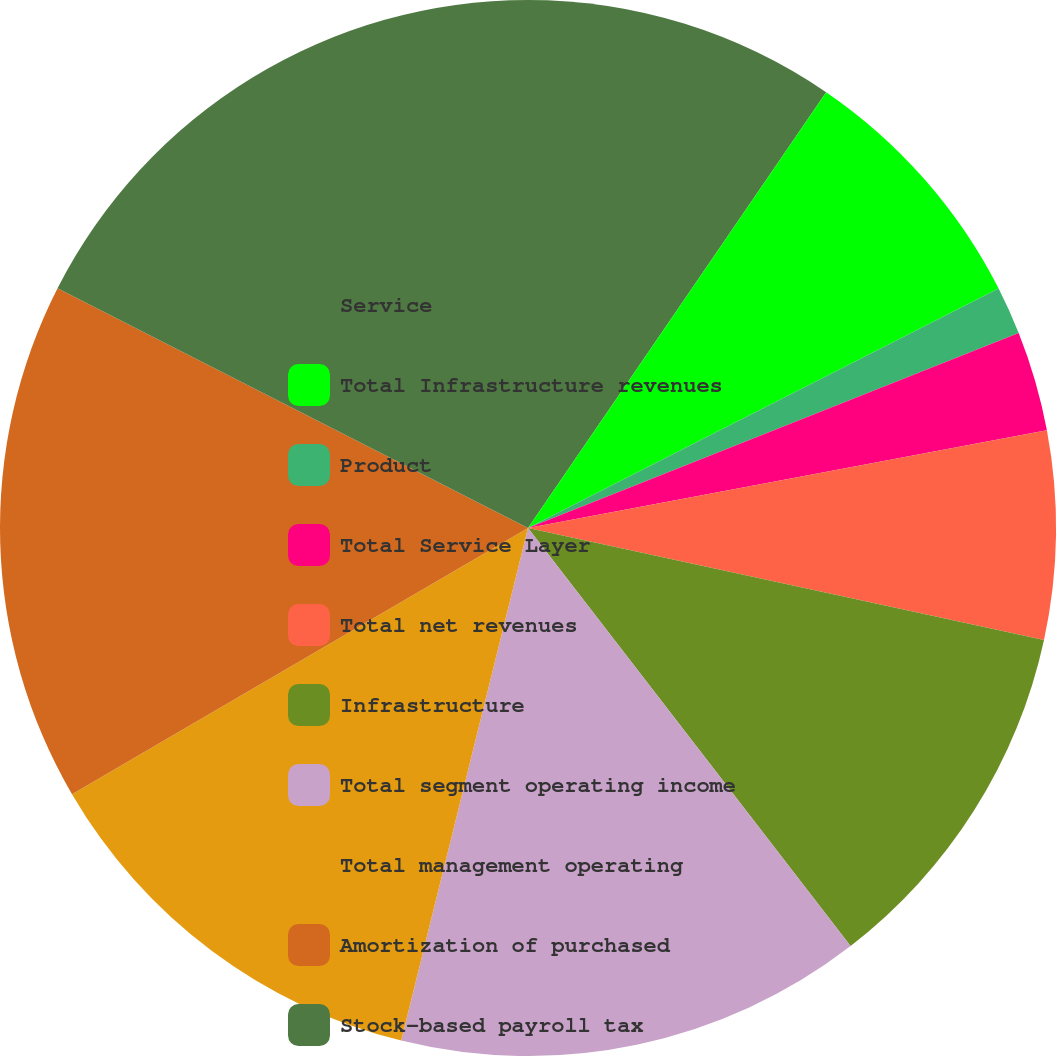Convert chart to OTSL. <chart><loc_0><loc_0><loc_500><loc_500><pie_chart><fcel>Service<fcel>Total Infrastructure revenues<fcel>Product<fcel>Total Service Layer<fcel>Total net revenues<fcel>Infrastructure<fcel>Total segment operating income<fcel>Total management operating<fcel>Amortization of purchased<fcel>Stock-based payroll tax<nl><fcel>9.55%<fcel>7.96%<fcel>1.47%<fcel>3.06%<fcel>6.36%<fcel>11.14%<fcel>14.32%<fcel>12.73%<fcel>15.91%<fcel>17.5%<nl></chart> 